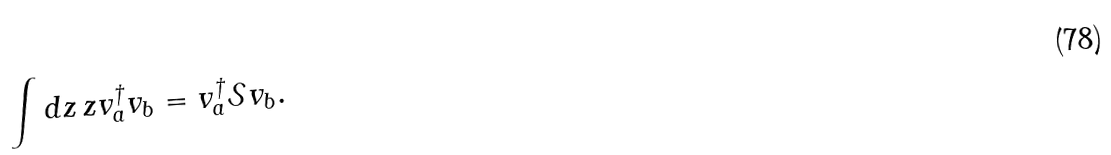Convert formula to latex. <formula><loc_0><loc_0><loc_500><loc_500>\int d z \, z { v } _ { a } ^ { \dagger } { v } _ { b } = { v } _ { a } ^ { \dagger } \mathcal { S } { v } _ { b } .</formula> 